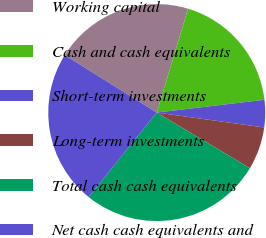Convert chart. <chart><loc_0><loc_0><loc_500><loc_500><pie_chart><fcel>Working capital<fcel>Cash and cash equivalents<fcel>Short-term investments<fcel>Long-term investments<fcel>Total cash cash equivalents<fcel>Net cash cash equivalents and<nl><fcel>20.77%<fcel>18.46%<fcel>4.07%<fcel>6.38%<fcel>27.22%<fcel>23.09%<nl></chart> 